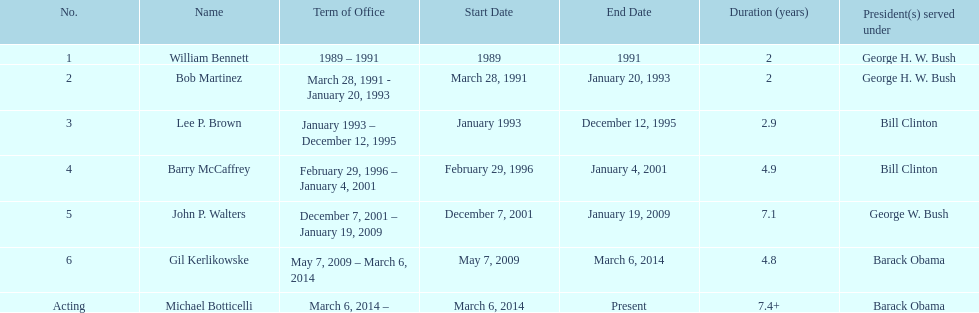When did john p. walters end his term? January 19, 2009. 